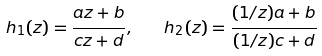Convert formula to latex. <formula><loc_0><loc_0><loc_500><loc_500>h _ { 1 } ( z ) = \frac { a z + b } { c z + d } , \quad h _ { 2 } ( z ) = \frac { ( 1 / z ) a + b } { ( 1 / z ) c + d }</formula> 